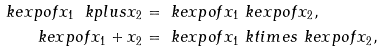<formula> <loc_0><loc_0><loc_500><loc_500>\ k e x p o f { x _ { 1 } \ k p l u s x _ { 2 } } & = \ k e x p o f { x _ { 1 } } \ k e x p o f { x _ { 2 } } , \\ \ k e x p o f { x _ { 1 } + x _ { 2 } } & = \ k e x p o f { x _ { 1 } } \ k t i m e s \ k e x p o f { x _ { 2 } } ,</formula> 